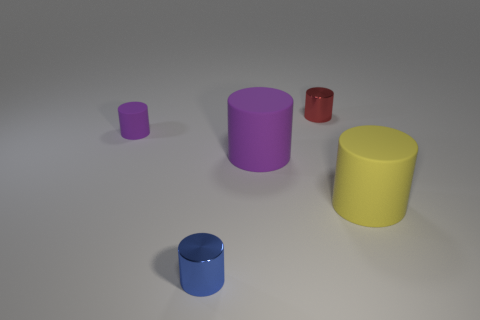There is a cylinder that is on the right side of the small shiny cylinder that is behind the shiny thing that is to the left of the small red metallic cylinder; what size is it?
Your answer should be compact. Large. Are there any large cylinders on the left side of the big yellow cylinder?
Provide a short and direct response. Yes. What is the size of the other purple cylinder that is the same material as the tiny purple cylinder?
Make the answer very short. Large. What number of other yellow matte objects have the same shape as the yellow object?
Provide a short and direct response. 0. Do the tiny blue cylinder and the big object behind the large yellow thing have the same material?
Keep it short and to the point. No. Are there more yellow matte things left of the small purple matte object than matte cylinders?
Your response must be concise. No. What is the shape of the big object that is the same color as the tiny matte cylinder?
Provide a succinct answer. Cylinder. Are there any big purple cylinders made of the same material as the small blue cylinder?
Keep it short and to the point. No. Is the small object that is on the right side of the big purple object made of the same material as the purple thing on the left side of the small blue cylinder?
Keep it short and to the point. No. Are there an equal number of big purple cylinders that are behind the large purple object and tiny blue metal cylinders right of the small red metal cylinder?
Your response must be concise. Yes. 